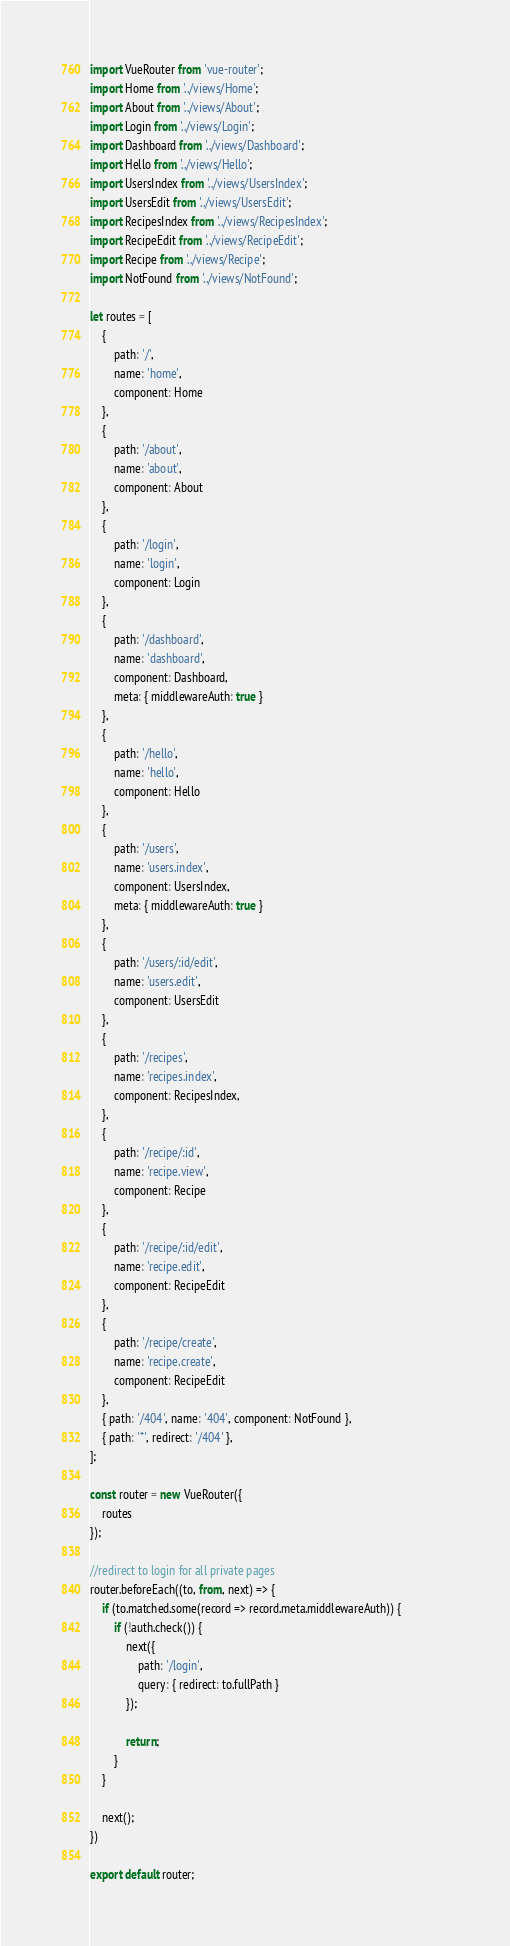Convert code to text. <code><loc_0><loc_0><loc_500><loc_500><_JavaScript_>import VueRouter from 'vue-router';
import Home from '../views/Home';
import About from '../views/About';
import Login from '../views/Login';
import Dashboard from '../views/Dashboard';
import Hello from '../views/Hello';
import UsersIndex from '../views/UsersIndex';
import UsersEdit from '../views/UsersEdit';
import RecipesIndex from '../views/RecipesIndex';
import RecipeEdit from '../views/RecipeEdit';
import Recipe from '../views/Recipe';
import NotFound from '../views/NotFound';

let routes = [
    {
        path: '/',
        name: 'home',
        component: Home
    },
    {
        path: '/about',
        name: 'about',
        component: About
    },
    {
        path: '/login',
        name: 'login',
        component: Login
    },
    {
        path: '/dashboard',
        name: 'dashboard',
        component: Dashboard,
        meta: { middlewareAuth: true }
    },
    {
        path: '/hello',
        name: 'hello',
        component: Hello
    },
    {
        path: '/users',
        name: 'users.index',
        component: UsersIndex,
        meta: { middlewareAuth: true }
    },
    {
        path: '/users/:id/edit',
        name: 'users.edit',
        component: UsersEdit
    },
    {
        path: '/recipes',
        name: 'recipes.index',
        component: RecipesIndex,
    },
    {
        path: '/recipe/:id',
        name: 'recipe.view',
        component: Recipe
    },
    {
        path: '/recipe/:id/edit',
        name: 'recipe.edit',
        component: RecipeEdit
    },
    {
        path: '/recipe/create',
        name: 'recipe.create',
        component: RecipeEdit
    },
    { path: '/404', name: '404', component: NotFound },
    { path: '*', redirect: '/404' },
];

const router = new VueRouter({
    routes
});

//redirect to login for all private pages
router.beforeEach((to, from, next) => {
    if (to.matched.some(record => record.meta.middlewareAuth)) {                
        if (!auth.check()) {
            next({
                path: '/login',
                query: { redirect: to.fullPath }
            });

            return;
        }
    }

    next();
})

export default router;</code> 